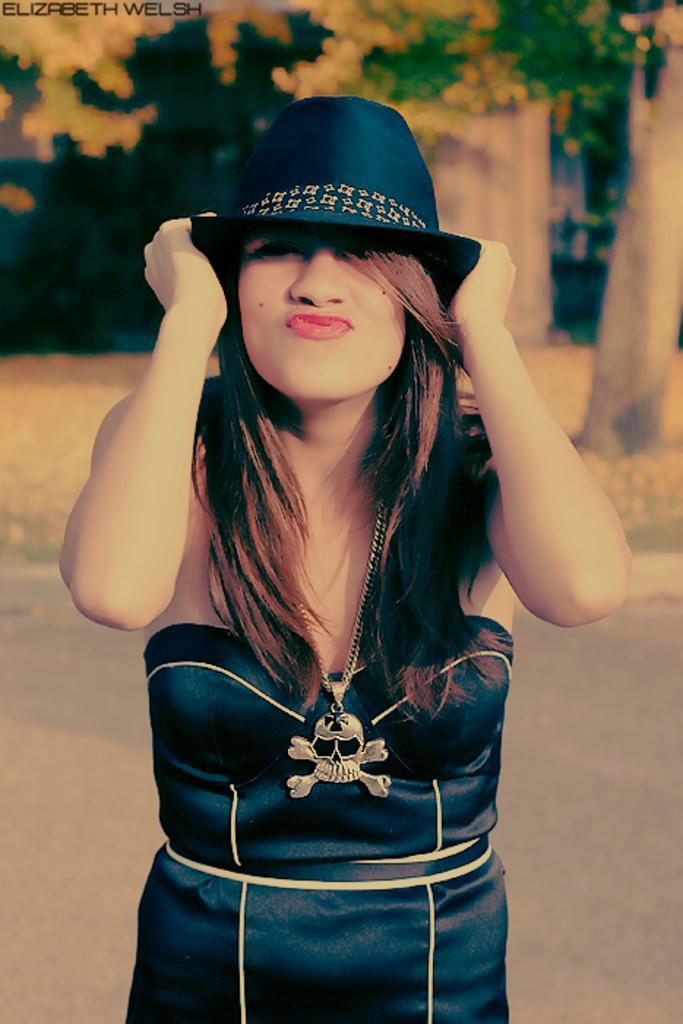Describe this image in one or two sentences. This is a close up image of a woman wearing clothes, neck chain and hat. The background is blurred. 